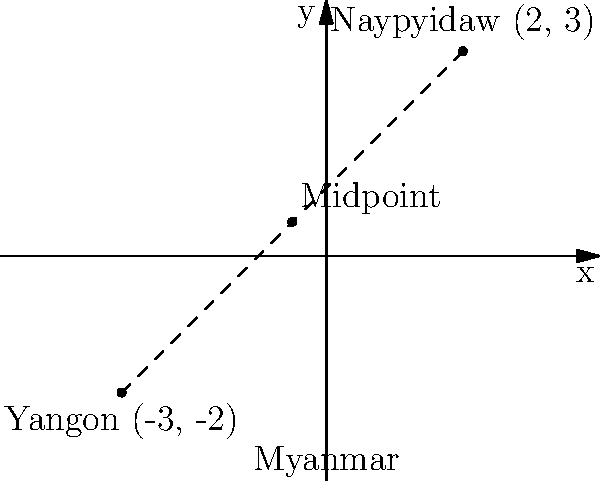In the context of Myanmar's political landscape, Naypyidaw (the capital) and Yangon (the largest city) are two significant locations. On a coordinate plane, Naypyidaw is represented by the point (2, 3) and Yangon by (-3, -2). What are the coordinates of the midpoint between these two politically important cities? To find the midpoint between two points, we use the midpoint formula:

$$ \text{Midpoint} = (\frac{x_1 + x_2}{2}, \frac{y_1 + y_2}{2}) $$

Where $(x_1, y_1)$ represents the coordinates of the first point and $(x_2, y_2)$ represents the coordinates of the second point.

1. Identify the coordinates:
   Naypyidaw: $(x_1, y_1) = (2, 3)$
   Yangon: $(x_2, y_2) = (-3, -2)$

2. Calculate the x-coordinate of the midpoint:
   $$ x = \frac{x_1 + x_2}{2} = \frac{2 + (-3)}{2} = \frac{-1}{2} = -0.5 $$

3. Calculate the y-coordinate of the midpoint:
   $$ y = \frac{y_1 + y_2}{2} = \frac{3 + (-2)}{2} = \frac{1}{2} = 0.5 $$

4. Combine the results:
   The midpoint coordinates are $(-0.5, 0.5)$

This midpoint could represent a location of political significance between the administrative capital (Naypyidaw) and the economic center (Yangon) of Myanmar.
Answer: $(-0.5, 0.5)$ 